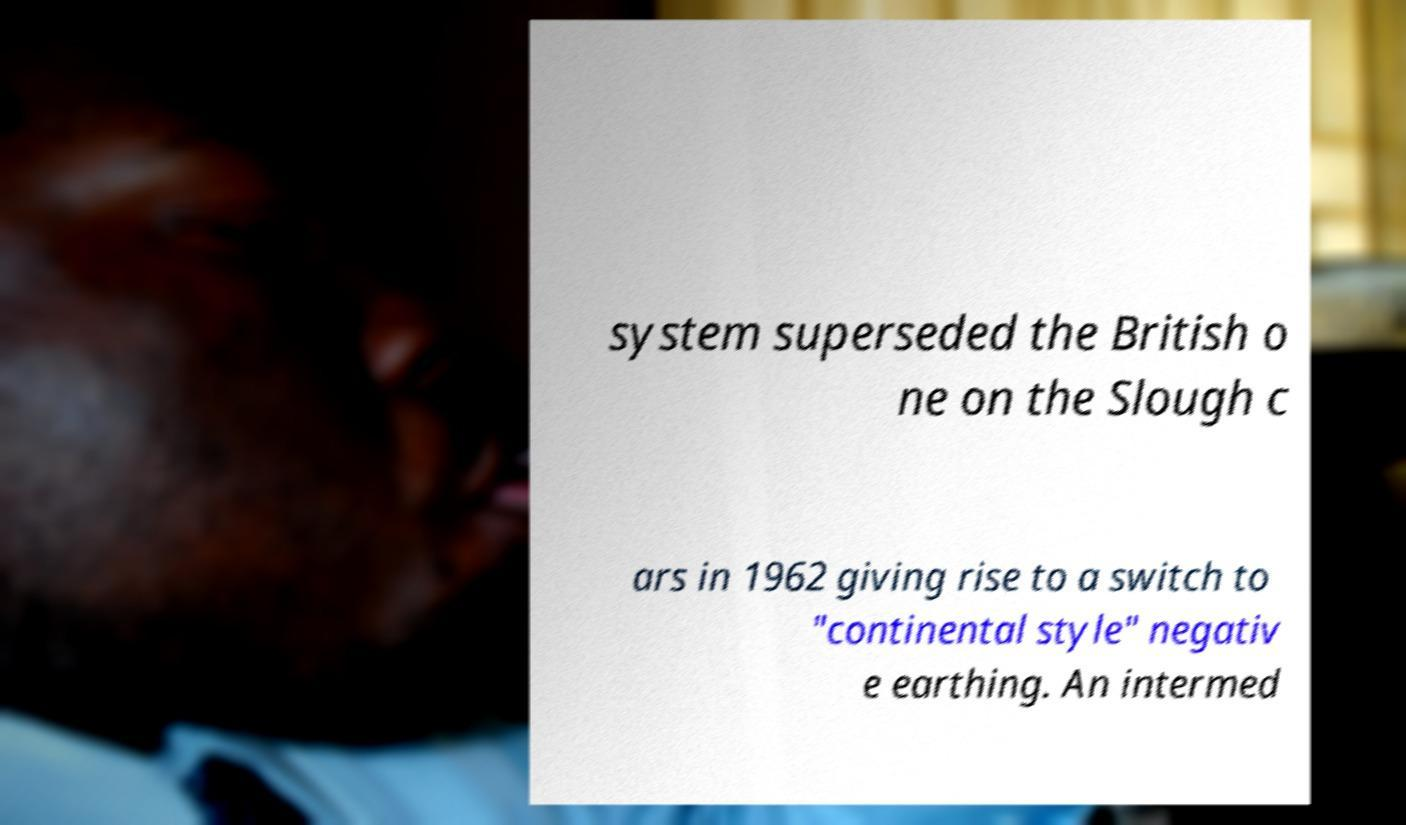Please identify and transcribe the text found in this image. system superseded the British o ne on the Slough c ars in 1962 giving rise to a switch to "continental style" negativ e earthing. An intermed 